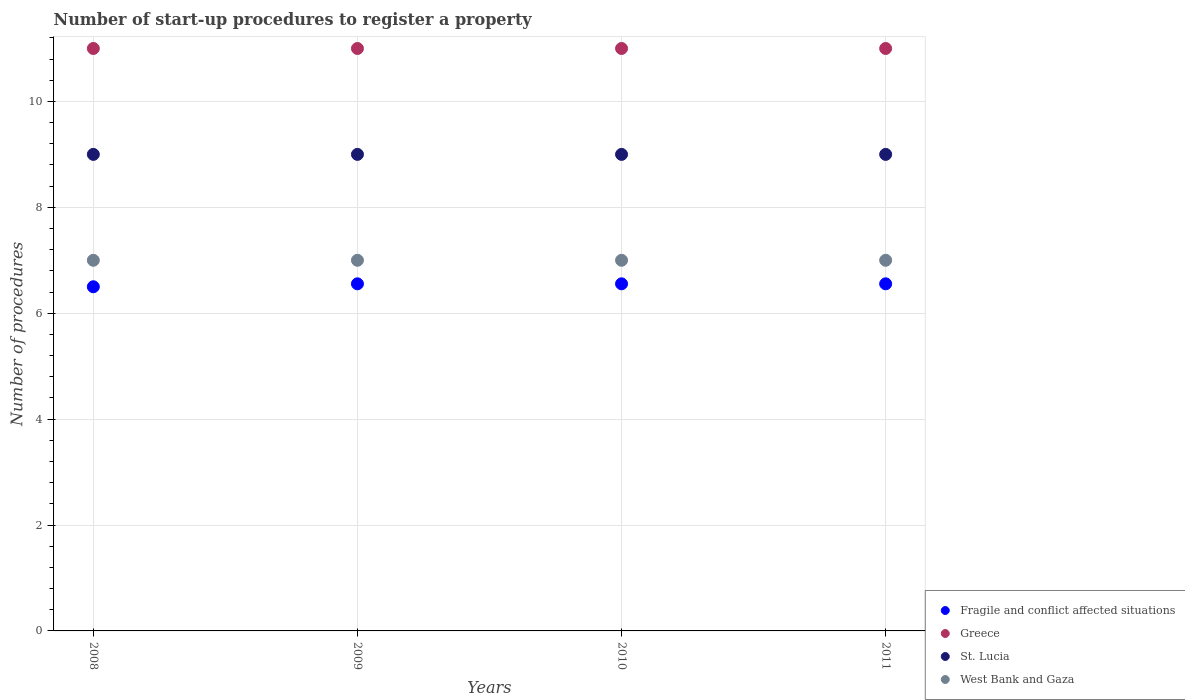Is the number of dotlines equal to the number of legend labels?
Your answer should be very brief. Yes. What is the number of procedures required to register a property in St. Lucia in 2008?
Make the answer very short. 9. Across all years, what is the maximum number of procedures required to register a property in Fragile and conflict affected situations?
Give a very brief answer. 6.56. Across all years, what is the minimum number of procedures required to register a property in Fragile and conflict affected situations?
Make the answer very short. 6.5. What is the difference between the number of procedures required to register a property in St. Lucia in 2008 and that in 2011?
Provide a short and direct response. 0. What is the difference between the number of procedures required to register a property in Greece in 2011 and the number of procedures required to register a property in West Bank and Gaza in 2008?
Provide a succinct answer. 4. What is the average number of procedures required to register a property in Fragile and conflict affected situations per year?
Offer a very short reply. 6.54. In the year 2010, what is the difference between the number of procedures required to register a property in Greece and number of procedures required to register a property in Fragile and conflict affected situations?
Your answer should be very brief. 4.44. What is the ratio of the number of procedures required to register a property in Fragile and conflict affected situations in 2008 to that in 2011?
Offer a terse response. 0.99. Is the number of procedures required to register a property in St. Lucia in 2008 less than that in 2010?
Your response must be concise. No. What is the difference between the highest and the lowest number of procedures required to register a property in Fragile and conflict affected situations?
Provide a short and direct response. 0.06. Is it the case that in every year, the sum of the number of procedures required to register a property in St. Lucia and number of procedures required to register a property in Fragile and conflict affected situations  is greater than the sum of number of procedures required to register a property in West Bank and Gaza and number of procedures required to register a property in Greece?
Your answer should be compact. Yes. Does the number of procedures required to register a property in Fragile and conflict affected situations monotonically increase over the years?
Give a very brief answer. No. Is the number of procedures required to register a property in West Bank and Gaza strictly greater than the number of procedures required to register a property in Fragile and conflict affected situations over the years?
Provide a succinct answer. Yes. How many years are there in the graph?
Your response must be concise. 4. What is the difference between two consecutive major ticks on the Y-axis?
Your response must be concise. 2. Are the values on the major ticks of Y-axis written in scientific E-notation?
Ensure brevity in your answer.  No. Does the graph contain any zero values?
Ensure brevity in your answer.  No. Does the graph contain grids?
Keep it short and to the point. Yes. How are the legend labels stacked?
Make the answer very short. Vertical. What is the title of the graph?
Make the answer very short. Number of start-up procedures to register a property. Does "Solomon Islands" appear as one of the legend labels in the graph?
Your response must be concise. No. What is the label or title of the Y-axis?
Your answer should be compact. Number of procedures. What is the Number of procedures of St. Lucia in 2008?
Offer a very short reply. 9. What is the Number of procedures in West Bank and Gaza in 2008?
Offer a terse response. 7. What is the Number of procedures of Fragile and conflict affected situations in 2009?
Your response must be concise. 6.56. What is the Number of procedures in St. Lucia in 2009?
Your answer should be compact. 9. What is the Number of procedures of West Bank and Gaza in 2009?
Keep it short and to the point. 7. What is the Number of procedures of Fragile and conflict affected situations in 2010?
Make the answer very short. 6.56. What is the Number of procedures of Fragile and conflict affected situations in 2011?
Offer a very short reply. 6.56. What is the Number of procedures of Greece in 2011?
Your answer should be very brief. 11. What is the Number of procedures of St. Lucia in 2011?
Provide a succinct answer. 9. What is the Number of procedures in West Bank and Gaza in 2011?
Offer a very short reply. 7. Across all years, what is the maximum Number of procedures in Fragile and conflict affected situations?
Offer a terse response. 6.56. Across all years, what is the maximum Number of procedures of St. Lucia?
Give a very brief answer. 9. Across all years, what is the maximum Number of procedures of West Bank and Gaza?
Make the answer very short. 7. Across all years, what is the minimum Number of procedures of Greece?
Provide a short and direct response. 11. Across all years, what is the minimum Number of procedures in St. Lucia?
Offer a very short reply. 9. Across all years, what is the minimum Number of procedures of West Bank and Gaza?
Provide a short and direct response. 7. What is the total Number of procedures of Fragile and conflict affected situations in the graph?
Offer a very short reply. 26.17. What is the total Number of procedures in Greece in the graph?
Give a very brief answer. 44. What is the total Number of procedures in St. Lucia in the graph?
Give a very brief answer. 36. What is the difference between the Number of procedures of Fragile and conflict affected situations in 2008 and that in 2009?
Offer a very short reply. -0.06. What is the difference between the Number of procedures in Greece in 2008 and that in 2009?
Your response must be concise. 0. What is the difference between the Number of procedures in St. Lucia in 2008 and that in 2009?
Offer a terse response. 0. What is the difference between the Number of procedures in Fragile and conflict affected situations in 2008 and that in 2010?
Make the answer very short. -0.06. What is the difference between the Number of procedures in West Bank and Gaza in 2008 and that in 2010?
Provide a short and direct response. 0. What is the difference between the Number of procedures of Fragile and conflict affected situations in 2008 and that in 2011?
Your answer should be compact. -0.06. What is the difference between the Number of procedures of Greece in 2008 and that in 2011?
Provide a short and direct response. 0. What is the difference between the Number of procedures of West Bank and Gaza in 2008 and that in 2011?
Your answer should be compact. 0. What is the difference between the Number of procedures of West Bank and Gaza in 2009 and that in 2010?
Give a very brief answer. 0. What is the difference between the Number of procedures in St. Lucia in 2009 and that in 2011?
Offer a terse response. 0. What is the difference between the Number of procedures of Fragile and conflict affected situations in 2008 and the Number of procedures of Greece in 2009?
Offer a very short reply. -4.5. What is the difference between the Number of procedures of Fragile and conflict affected situations in 2008 and the Number of procedures of St. Lucia in 2009?
Give a very brief answer. -2.5. What is the difference between the Number of procedures of Fragile and conflict affected situations in 2008 and the Number of procedures of West Bank and Gaza in 2009?
Your answer should be very brief. -0.5. What is the difference between the Number of procedures in Greece in 2008 and the Number of procedures in St. Lucia in 2009?
Offer a terse response. 2. What is the difference between the Number of procedures of Fragile and conflict affected situations in 2008 and the Number of procedures of Greece in 2010?
Provide a short and direct response. -4.5. What is the difference between the Number of procedures in Fragile and conflict affected situations in 2008 and the Number of procedures in West Bank and Gaza in 2010?
Provide a short and direct response. -0.5. What is the difference between the Number of procedures of Greece in 2008 and the Number of procedures of West Bank and Gaza in 2010?
Your answer should be very brief. 4. What is the difference between the Number of procedures of St. Lucia in 2008 and the Number of procedures of West Bank and Gaza in 2010?
Offer a very short reply. 2. What is the difference between the Number of procedures in Fragile and conflict affected situations in 2008 and the Number of procedures in Greece in 2011?
Your answer should be compact. -4.5. What is the difference between the Number of procedures of Fragile and conflict affected situations in 2008 and the Number of procedures of West Bank and Gaza in 2011?
Offer a very short reply. -0.5. What is the difference between the Number of procedures in St. Lucia in 2008 and the Number of procedures in West Bank and Gaza in 2011?
Give a very brief answer. 2. What is the difference between the Number of procedures of Fragile and conflict affected situations in 2009 and the Number of procedures of Greece in 2010?
Your answer should be very brief. -4.44. What is the difference between the Number of procedures of Fragile and conflict affected situations in 2009 and the Number of procedures of St. Lucia in 2010?
Your answer should be compact. -2.44. What is the difference between the Number of procedures in Fragile and conflict affected situations in 2009 and the Number of procedures in West Bank and Gaza in 2010?
Keep it short and to the point. -0.44. What is the difference between the Number of procedures in Greece in 2009 and the Number of procedures in West Bank and Gaza in 2010?
Provide a succinct answer. 4. What is the difference between the Number of procedures of St. Lucia in 2009 and the Number of procedures of West Bank and Gaza in 2010?
Provide a short and direct response. 2. What is the difference between the Number of procedures in Fragile and conflict affected situations in 2009 and the Number of procedures in Greece in 2011?
Provide a succinct answer. -4.44. What is the difference between the Number of procedures of Fragile and conflict affected situations in 2009 and the Number of procedures of St. Lucia in 2011?
Make the answer very short. -2.44. What is the difference between the Number of procedures in Fragile and conflict affected situations in 2009 and the Number of procedures in West Bank and Gaza in 2011?
Keep it short and to the point. -0.44. What is the difference between the Number of procedures in St. Lucia in 2009 and the Number of procedures in West Bank and Gaza in 2011?
Provide a short and direct response. 2. What is the difference between the Number of procedures of Fragile and conflict affected situations in 2010 and the Number of procedures of Greece in 2011?
Make the answer very short. -4.44. What is the difference between the Number of procedures of Fragile and conflict affected situations in 2010 and the Number of procedures of St. Lucia in 2011?
Ensure brevity in your answer.  -2.44. What is the difference between the Number of procedures of Fragile and conflict affected situations in 2010 and the Number of procedures of West Bank and Gaza in 2011?
Keep it short and to the point. -0.44. What is the average Number of procedures of Fragile and conflict affected situations per year?
Give a very brief answer. 6.54. What is the average Number of procedures in Greece per year?
Give a very brief answer. 11. What is the average Number of procedures in West Bank and Gaza per year?
Provide a short and direct response. 7. In the year 2008, what is the difference between the Number of procedures in Fragile and conflict affected situations and Number of procedures in Greece?
Provide a succinct answer. -4.5. In the year 2008, what is the difference between the Number of procedures of Fragile and conflict affected situations and Number of procedures of West Bank and Gaza?
Your response must be concise. -0.5. In the year 2008, what is the difference between the Number of procedures of Greece and Number of procedures of West Bank and Gaza?
Make the answer very short. 4. In the year 2008, what is the difference between the Number of procedures of St. Lucia and Number of procedures of West Bank and Gaza?
Give a very brief answer. 2. In the year 2009, what is the difference between the Number of procedures of Fragile and conflict affected situations and Number of procedures of Greece?
Provide a short and direct response. -4.44. In the year 2009, what is the difference between the Number of procedures of Fragile and conflict affected situations and Number of procedures of St. Lucia?
Provide a succinct answer. -2.44. In the year 2009, what is the difference between the Number of procedures of Fragile and conflict affected situations and Number of procedures of West Bank and Gaza?
Your answer should be very brief. -0.44. In the year 2009, what is the difference between the Number of procedures of Greece and Number of procedures of West Bank and Gaza?
Your answer should be compact. 4. In the year 2010, what is the difference between the Number of procedures of Fragile and conflict affected situations and Number of procedures of Greece?
Your response must be concise. -4.44. In the year 2010, what is the difference between the Number of procedures in Fragile and conflict affected situations and Number of procedures in St. Lucia?
Provide a short and direct response. -2.44. In the year 2010, what is the difference between the Number of procedures in Fragile and conflict affected situations and Number of procedures in West Bank and Gaza?
Offer a very short reply. -0.44. In the year 2010, what is the difference between the Number of procedures in Greece and Number of procedures in St. Lucia?
Your answer should be very brief. 2. In the year 2010, what is the difference between the Number of procedures in Greece and Number of procedures in West Bank and Gaza?
Offer a terse response. 4. In the year 2010, what is the difference between the Number of procedures in St. Lucia and Number of procedures in West Bank and Gaza?
Ensure brevity in your answer.  2. In the year 2011, what is the difference between the Number of procedures of Fragile and conflict affected situations and Number of procedures of Greece?
Ensure brevity in your answer.  -4.44. In the year 2011, what is the difference between the Number of procedures of Fragile and conflict affected situations and Number of procedures of St. Lucia?
Ensure brevity in your answer.  -2.44. In the year 2011, what is the difference between the Number of procedures in Fragile and conflict affected situations and Number of procedures in West Bank and Gaza?
Offer a very short reply. -0.44. In the year 2011, what is the difference between the Number of procedures in Greece and Number of procedures in St. Lucia?
Ensure brevity in your answer.  2. What is the ratio of the Number of procedures of Fragile and conflict affected situations in 2008 to that in 2009?
Make the answer very short. 0.99. What is the ratio of the Number of procedures in Greece in 2008 to that in 2009?
Ensure brevity in your answer.  1. What is the ratio of the Number of procedures in West Bank and Gaza in 2008 to that in 2009?
Your response must be concise. 1. What is the ratio of the Number of procedures of Greece in 2008 to that in 2010?
Make the answer very short. 1. What is the ratio of the Number of procedures in Fragile and conflict affected situations in 2008 to that in 2011?
Offer a very short reply. 0.99. What is the ratio of the Number of procedures in St. Lucia in 2008 to that in 2011?
Your answer should be very brief. 1. What is the ratio of the Number of procedures of West Bank and Gaza in 2008 to that in 2011?
Keep it short and to the point. 1. What is the ratio of the Number of procedures in Fragile and conflict affected situations in 2009 to that in 2010?
Give a very brief answer. 1. What is the ratio of the Number of procedures in Greece in 2009 to that in 2010?
Offer a very short reply. 1. What is the ratio of the Number of procedures in St. Lucia in 2009 to that in 2010?
Make the answer very short. 1. What is the ratio of the Number of procedures in Fragile and conflict affected situations in 2009 to that in 2011?
Keep it short and to the point. 1. What is the ratio of the Number of procedures of Greece in 2009 to that in 2011?
Give a very brief answer. 1. What is the ratio of the Number of procedures of St. Lucia in 2009 to that in 2011?
Your response must be concise. 1. What is the ratio of the Number of procedures in Greece in 2010 to that in 2011?
Provide a short and direct response. 1. What is the difference between the highest and the second highest Number of procedures in Fragile and conflict affected situations?
Keep it short and to the point. 0. What is the difference between the highest and the lowest Number of procedures of Fragile and conflict affected situations?
Provide a succinct answer. 0.06. What is the difference between the highest and the lowest Number of procedures in Greece?
Your response must be concise. 0. What is the difference between the highest and the lowest Number of procedures of St. Lucia?
Ensure brevity in your answer.  0. 